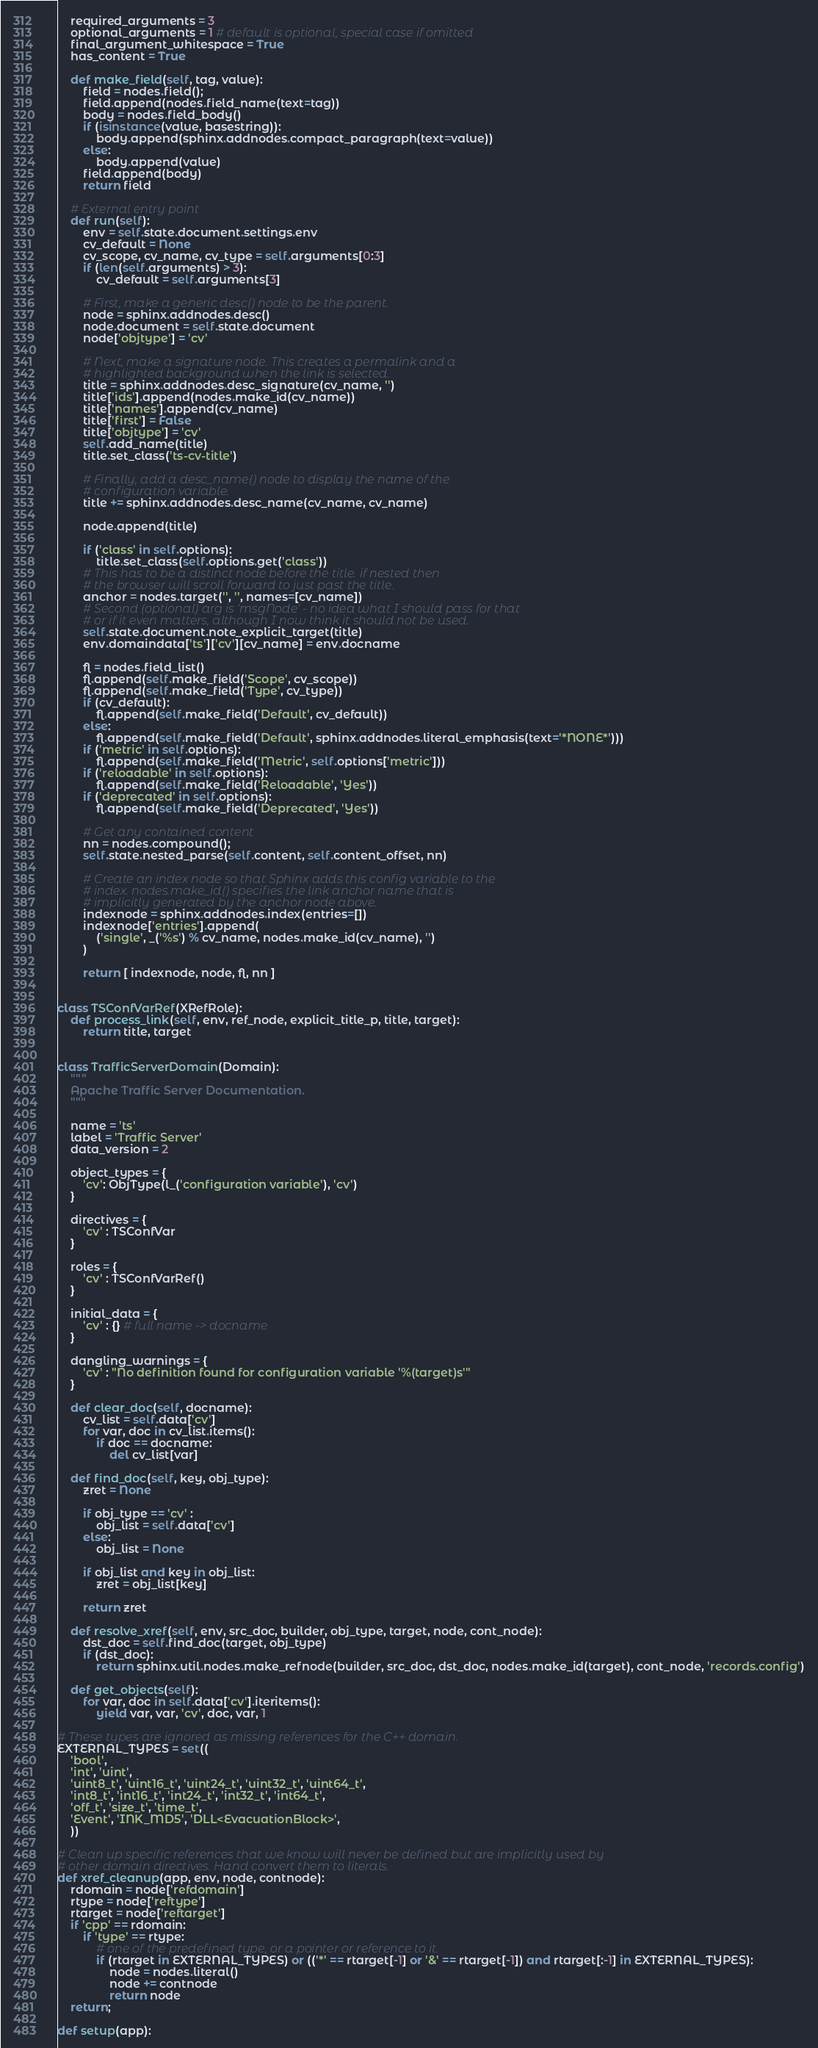Convert code to text. <code><loc_0><loc_0><loc_500><loc_500><_Python_>    required_arguments = 3
    optional_arguments = 1 # default is optional, special case if omitted
    final_argument_whitespace = True
    has_content = True

    def make_field(self, tag, value):
        field = nodes.field();
        field.append(nodes.field_name(text=tag))
        body = nodes.field_body()
        if (isinstance(value, basestring)):
            body.append(sphinx.addnodes.compact_paragraph(text=value))
        else:
            body.append(value)
        field.append(body)
        return field

    # External entry point
    def run(self):
        env = self.state.document.settings.env
        cv_default = None
        cv_scope, cv_name, cv_type = self.arguments[0:3]
        if (len(self.arguments) > 3):
            cv_default = self.arguments[3]

        # First, make a generic desc() node to be the parent.
        node = sphinx.addnodes.desc()
        node.document = self.state.document
        node['objtype'] = 'cv'

        # Next, make a signature node. This creates a permalink and a
        # highlighted background when the link is selected.
        title = sphinx.addnodes.desc_signature(cv_name, '')
        title['ids'].append(nodes.make_id(cv_name))
        title['names'].append(cv_name)
        title['first'] = False
        title['objtype'] = 'cv'
        self.add_name(title)
        title.set_class('ts-cv-title')

        # Finally, add a desc_name() node to display the name of the
        # configuration variable.
        title += sphinx.addnodes.desc_name(cv_name, cv_name)

        node.append(title)

        if ('class' in self.options):
            title.set_class(self.options.get('class'))
        # This has to be a distinct node before the title. if nested then
        # the browser will scroll forward to just past the title.
        anchor = nodes.target('', '', names=[cv_name])
        # Second (optional) arg is 'msgNode' - no idea what I should pass for that
        # or if it even matters, although I now think it should not be used.
        self.state.document.note_explicit_target(title)
        env.domaindata['ts']['cv'][cv_name] = env.docname

        fl = nodes.field_list()
        fl.append(self.make_field('Scope', cv_scope))
        fl.append(self.make_field('Type', cv_type))
        if (cv_default):
            fl.append(self.make_field('Default', cv_default))
        else:
            fl.append(self.make_field('Default', sphinx.addnodes.literal_emphasis(text='*NONE*')))
        if ('metric' in self.options):
            fl.append(self.make_field('Metric', self.options['metric']))
        if ('reloadable' in self.options):
            fl.append(self.make_field('Reloadable', 'Yes'))
        if ('deprecated' in self.options):
            fl.append(self.make_field('Deprecated', 'Yes'))

        # Get any contained content
        nn = nodes.compound();
        self.state.nested_parse(self.content, self.content_offset, nn)

        # Create an index node so that Sphinx adds this config variable to the
        # index. nodes.make_id() specifies the link anchor name that is
        # implicitly generated by the anchor node above.
        indexnode = sphinx.addnodes.index(entries=[])
        indexnode['entries'].append(
            ('single', _('%s') % cv_name, nodes.make_id(cv_name), '')
        )

        return [ indexnode, node, fl, nn ]


class TSConfVarRef(XRefRole):
    def process_link(self, env, ref_node, explicit_title_p, title, target):
        return title, target


class TrafficServerDomain(Domain):
    """
    Apache Traffic Server Documentation.
    """

    name = 'ts'
    label = 'Traffic Server'
    data_version = 2

    object_types = {
        'cv': ObjType(l_('configuration variable'), 'cv')
    }

    directives = {
        'cv' : TSConfVar
    }

    roles = {
        'cv' : TSConfVarRef()
    }

    initial_data = {
        'cv' : {} # full name -> docname
    }

    dangling_warnings = {
        'cv' : "No definition found for configuration variable '%(target)s'"
    }

    def clear_doc(self, docname):
        cv_list = self.data['cv']
        for var, doc in cv_list.items():
            if doc == docname:
                del cv_list[var]

    def find_doc(self, key, obj_type):
        zret = None

        if obj_type == 'cv' :
            obj_list = self.data['cv']
        else:
            obj_list = None

        if obj_list and key in obj_list:
            zret = obj_list[key]

        return zret

    def resolve_xref(self, env, src_doc, builder, obj_type, target, node, cont_node):
        dst_doc = self.find_doc(target, obj_type)
        if (dst_doc):
            return sphinx.util.nodes.make_refnode(builder, src_doc, dst_doc, nodes.make_id(target), cont_node, 'records.config')

    def get_objects(self):
        for var, doc in self.data['cv'].iteritems():
            yield var, var, 'cv', doc, var, 1

# These types are ignored as missing references for the C++ domain.
EXTERNAL_TYPES = set((
    'bool',
    'int', 'uint',
    'uint8_t', 'uint16_t', 'uint24_t', 'uint32_t', 'uint64_t',
    'int8_t', 'int16_t', 'int24_t', 'int32_t', 'int64_t',
    'off_t', 'size_t', 'time_t',
    'Event', 'INK_MD5', 'DLL<EvacuationBlock>',
    ))

# Clean up specific references that we know will never be defined but are implicitly used by
# other domain directives. Hand convert them to literals.
def xref_cleanup(app, env, node, contnode):
    rdomain = node['refdomain']
    rtype = node['reftype']
    rtarget = node['reftarget']
    if 'cpp' == rdomain:
        if 'type' == rtype:
            # one of the predefined type, or a pointer or reference to it.
            if (rtarget in EXTERNAL_TYPES) or (('*' == rtarget[-1] or '&' == rtarget[-1]) and rtarget[:-1] in EXTERNAL_TYPES):
                node = nodes.literal()
                node += contnode
                return node
    return;

def setup(app):</code> 